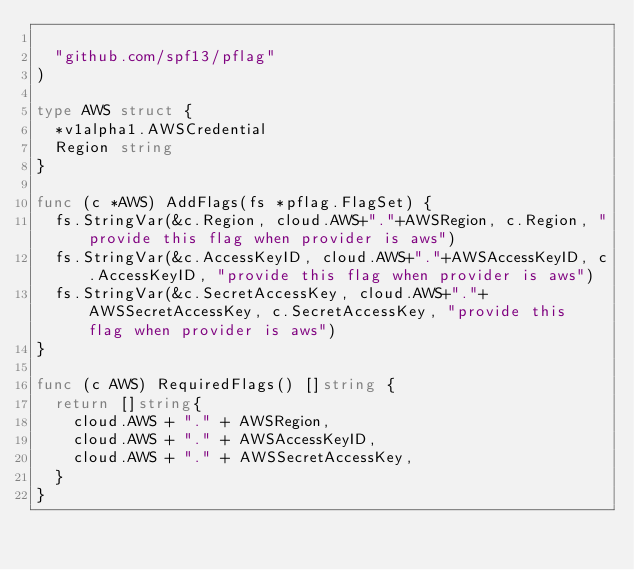<code> <loc_0><loc_0><loc_500><loc_500><_Go_>
	"github.com/spf13/pflag"
)

type AWS struct {
	*v1alpha1.AWSCredential
	Region string
}

func (c *AWS) AddFlags(fs *pflag.FlagSet) {
	fs.StringVar(&c.Region, cloud.AWS+"."+AWSRegion, c.Region, "provide this flag when provider is aws")
	fs.StringVar(&c.AccessKeyID, cloud.AWS+"."+AWSAccessKeyID, c.AccessKeyID, "provide this flag when provider is aws")
	fs.StringVar(&c.SecretAccessKey, cloud.AWS+"."+AWSSecretAccessKey, c.SecretAccessKey, "provide this flag when provider is aws")
}

func (c AWS) RequiredFlags() []string {
	return []string{
		cloud.AWS + "." + AWSRegion,
		cloud.AWS + "." + AWSAccessKeyID,
		cloud.AWS + "." + AWSSecretAccessKey,
	}
}
</code> 